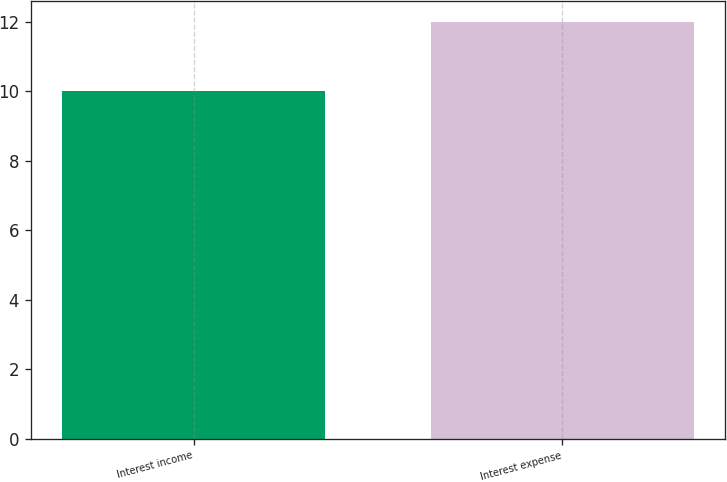Convert chart. <chart><loc_0><loc_0><loc_500><loc_500><bar_chart><fcel>Interest income<fcel>Interest expense<nl><fcel>10<fcel>12<nl></chart> 